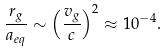Convert formula to latex. <formula><loc_0><loc_0><loc_500><loc_500>\frac { r _ { g } } { a _ { e q } } \sim \left ( \frac { v _ { g } } { c } \right ) ^ { 2 } \approx 1 0 ^ { - 4 } .</formula> 